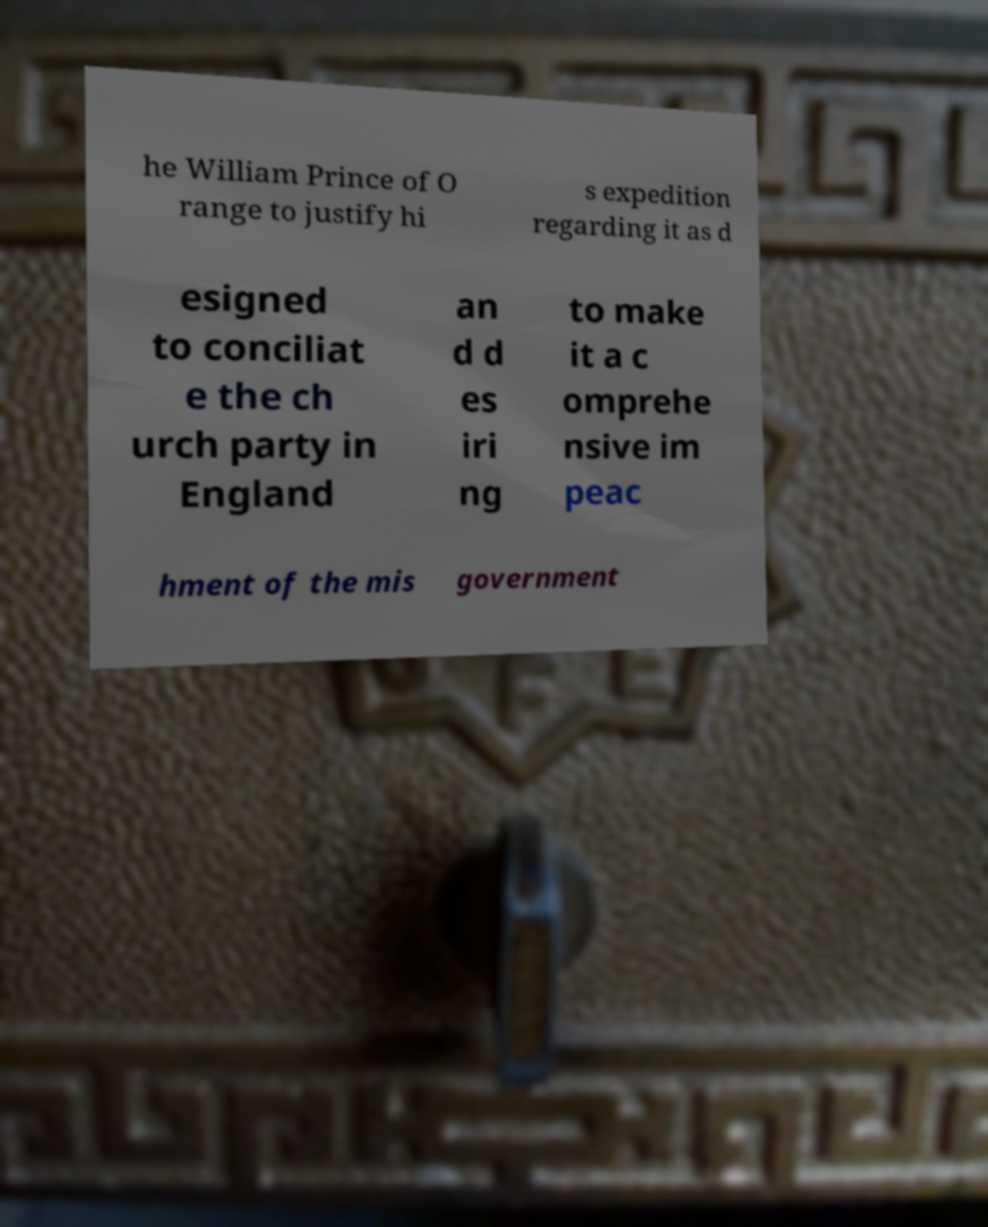Please identify and transcribe the text found in this image. he William Prince of O range to justify hi s expedition regarding it as d esigned to conciliat e the ch urch party in England an d d es iri ng to make it a c omprehe nsive im peac hment of the mis government 